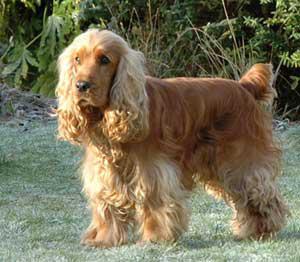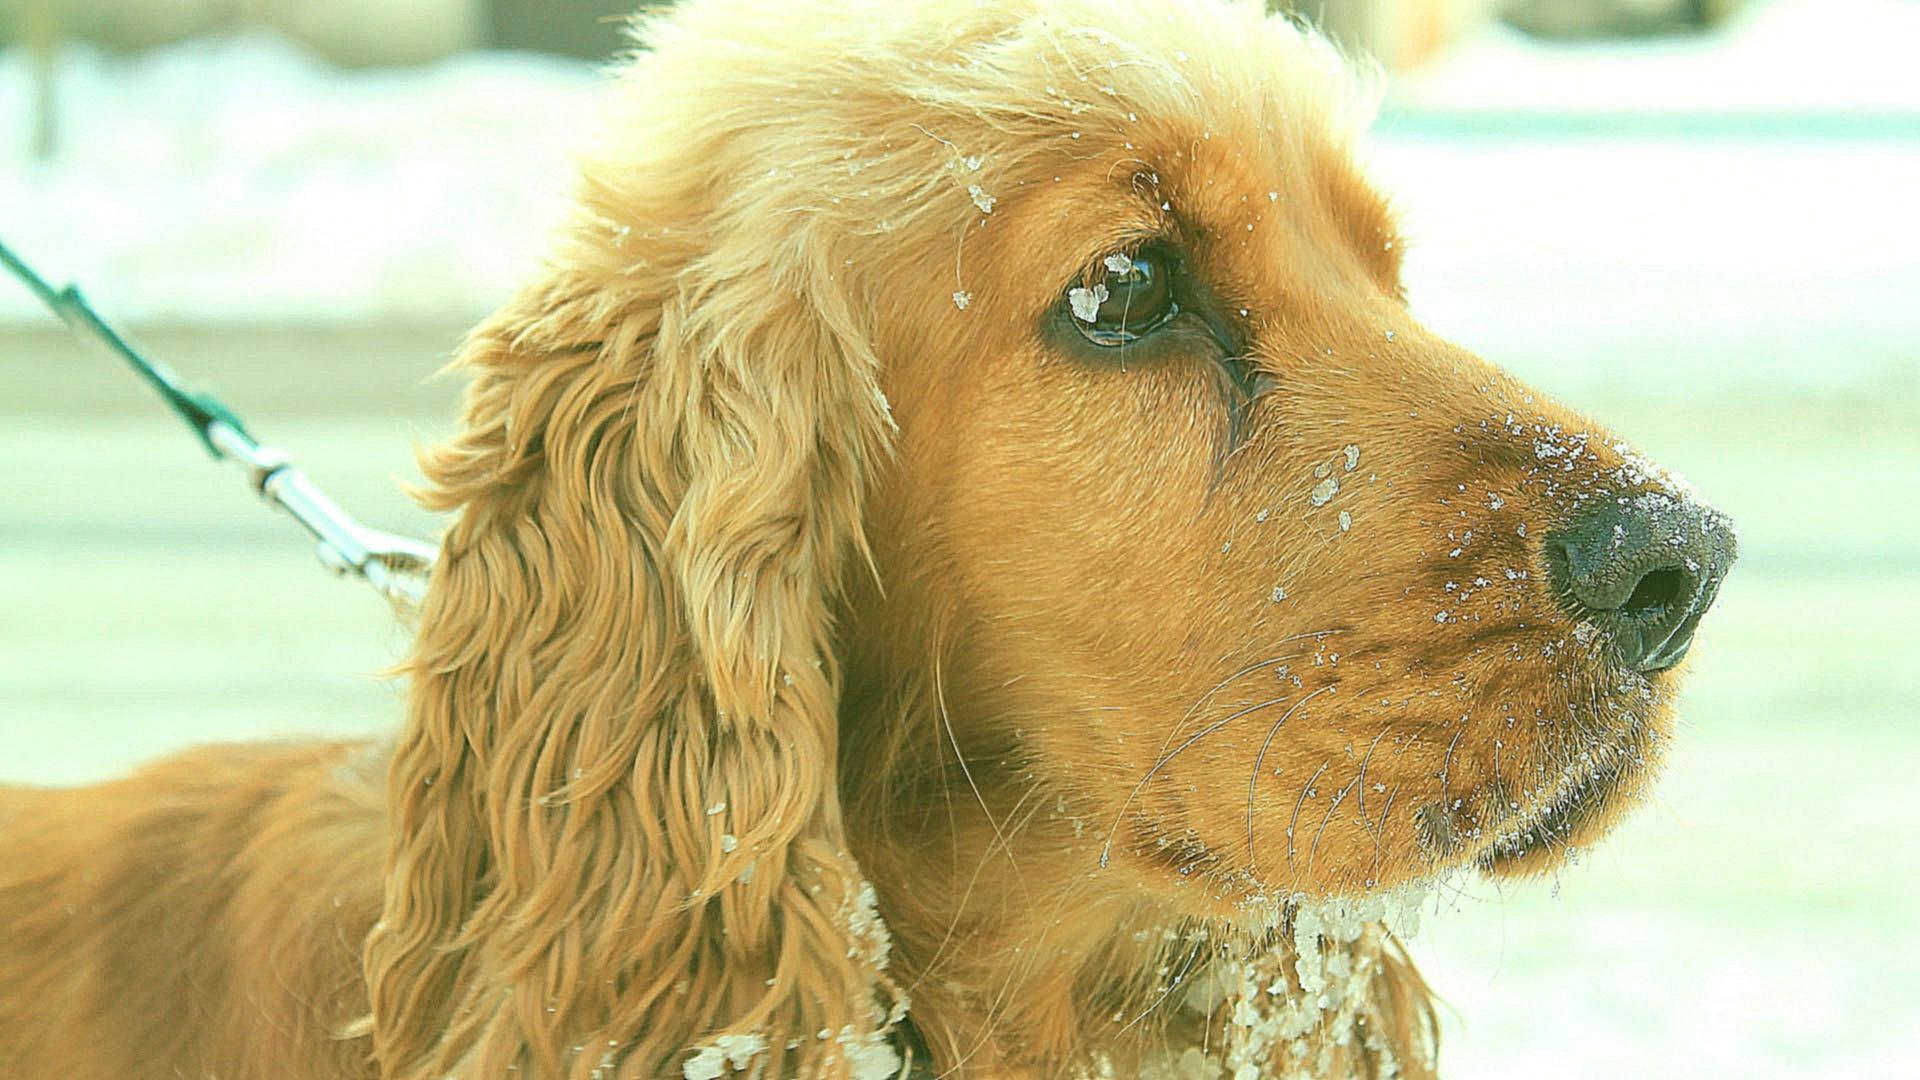The first image is the image on the left, the second image is the image on the right. Examine the images to the left and right. Is the description "At least one of the dogs is laying down." accurate? Answer yes or no. No. The first image is the image on the left, the second image is the image on the right. Given the left and right images, does the statement "One curly eared dog is facing right." hold true? Answer yes or no. Yes. 